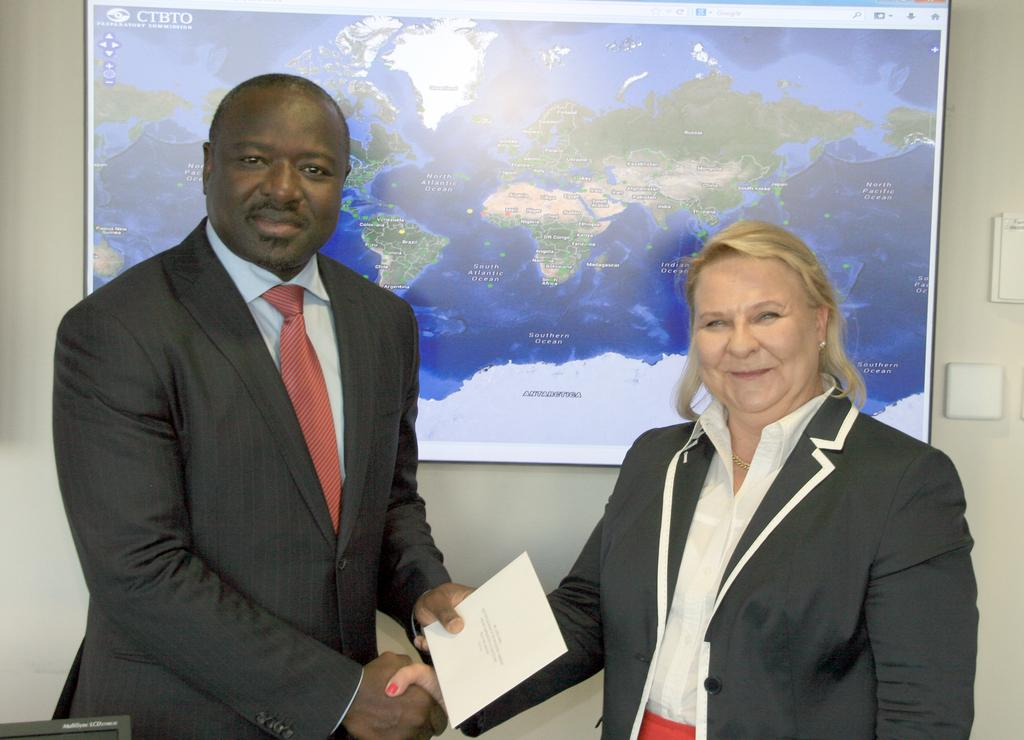How many people are in the image? There are people in the image, but the exact number is not specified. What are the people doing in the image? The people are standing and shaking hands. What can be seen in the background of the image? There is a map in the background of the image. What type of trick is being performed by the people in the image? There is no trick being performed by the people in the image; they are simply shaking hands. Can you tell me how many walls are visible in the image? There is no mention of walls in the image; it only features people shaking hands and a map in the background. 